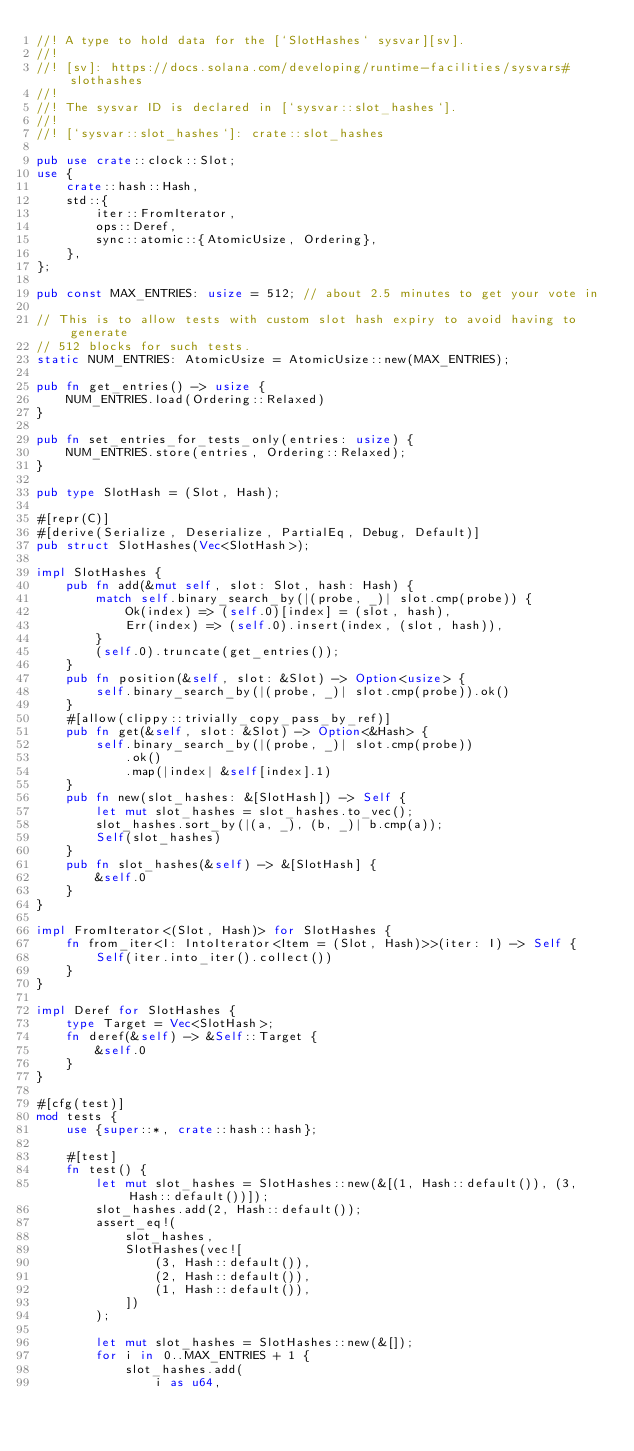Convert code to text. <code><loc_0><loc_0><loc_500><loc_500><_Rust_>//! A type to hold data for the [`SlotHashes` sysvar][sv].
//!
//! [sv]: https://docs.solana.com/developing/runtime-facilities/sysvars#slothashes
//!
//! The sysvar ID is declared in [`sysvar::slot_hashes`].
//!
//! [`sysvar::slot_hashes`]: crate::slot_hashes

pub use crate::clock::Slot;
use {
    crate::hash::Hash,
    std::{
        iter::FromIterator,
        ops::Deref,
        sync::atomic::{AtomicUsize, Ordering},
    },
};

pub const MAX_ENTRIES: usize = 512; // about 2.5 minutes to get your vote in

// This is to allow tests with custom slot hash expiry to avoid having to generate
// 512 blocks for such tests.
static NUM_ENTRIES: AtomicUsize = AtomicUsize::new(MAX_ENTRIES);

pub fn get_entries() -> usize {
    NUM_ENTRIES.load(Ordering::Relaxed)
}

pub fn set_entries_for_tests_only(entries: usize) {
    NUM_ENTRIES.store(entries, Ordering::Relaxed);
}

pub type SlotHash = (Slot, Hash);

#[repr(C)]
#[derive(Serialize, Deserialize, PartialEq, Debug, Default)]
pub struct SlotHashes(Vec<SlotHash>);

impl SlotHashes {
    pub fn add(&mut self, slot: Slot, hash: Hash) {
        match self.binary_search_by(|(probe, _)| slot.cmp(probe)) {
            Ok(index) => (self.0)[index] = (slot, hash),
            Err(index) => (self.0).insert(index, (slot, hash)),
        }
        (self.0).truncate(get_entries());
    }
    pub fn position(&self, slot: &Slot) -> Option<usize> {
        self.binary_search_by(|(probe, _)| slot.cmp(probe)).ok()
    }
    #[allow(clippy::trivially_copy_pass_by_ref)]
    pub fn get(&self, slot: &Slot) -> Option<&Hash> {
        self.binary_search_by(|(probe, _)| slot.cmp(probe))
            .ok()
            .map(|index| &self[index].1)
    }
    pub fn new(slot_hashes: &[SlotHash]) -> Self {
        let mut slot_hashes = slot_hashes.to_vec();
        slot_hashes.sort_by(|(a, _), (b, _)| b.cmp(a));
        Self(slot_hashes)
    }
    pub fn slot_hashes(&self) -> &[SlotHash] {
        &self.0
    }
}

impl FromIterator<(Slot, Hash)> for SlotHashes {
    fn from_iter<I: IntoIterator<Item = (Slot, Hash)>>(iter: I) -> Self {
        Self(iter.into_iter().collect())
    }
}

impl Deref for SlotHashes {
    type Target = Vec<SlotHash>;
    fn deref(&self) -> &Self::Target {
        &self.0
    }
}

#[cfg(test)]
mod tests {
    use {super::*, crate::hash::hash};

    #[test]
    fn test() {
        let mut slot_hashes = SlotHashes::new(&[(1, Hash::default()), (3, Hash::default())]);
        slot_hashes.add(2, Hash::default());
        assert_eq!(
            slot_hashes,
            SlotHashes(vec![
                (3, Hash::default()),
                (2, Hash::default()),
                (1, Hash::default()),
            ])
        );

        let mut slot_hashes = SlotHashes::new(&[]);
        for i in 0..MAX_ENTRIES + 1 {
            slot_hashes.add(
                i as u64,</code> 